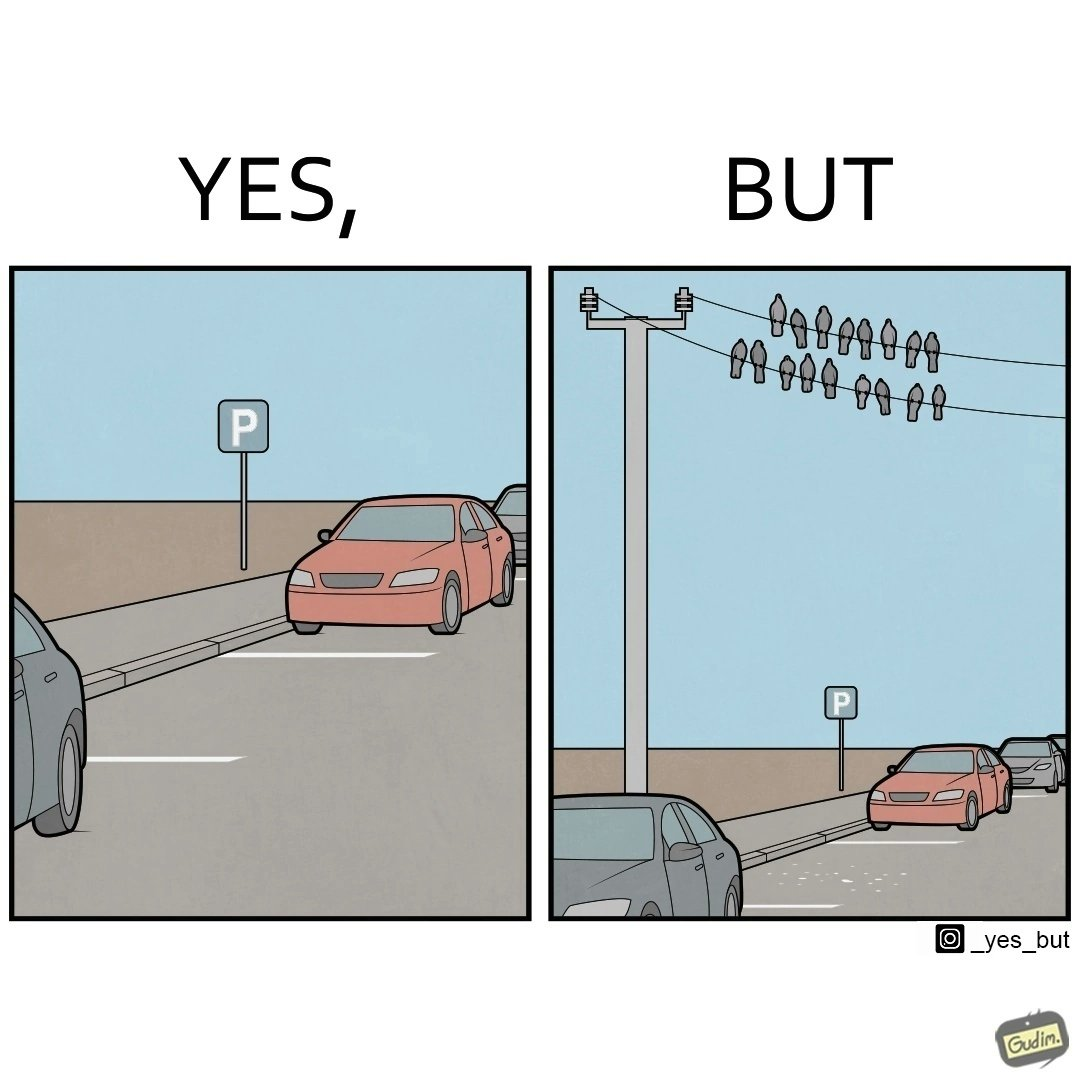What is shown in this image? The image is ironical such that although there is a place for parking but that place is not suitable because if we place our car there then our car will become dirty from top due to crow beet. 